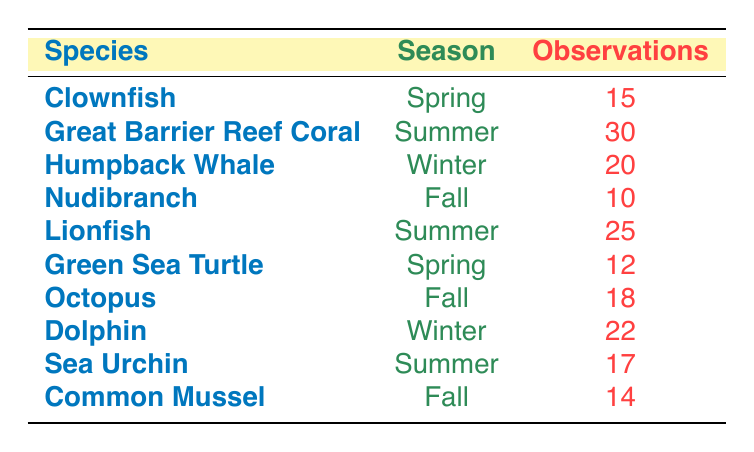What is the species with the highest observations during the Summer? In the Summer season, the species with the highest observations listed in the table is the Great Barrier Reef Coral with 30 observations.
Answer: Great Barrier Reef Coral How many observations were recorded for the Dolphin? The Dolphin species has 22 observations recorded in the table under the Winter season.
Answer: 22 Which season had the least total observations from the listed species? Adding all the observations by season, Spring has 15 (Clownfish) + 12 (Green Sea Turtle) = 27, Summer has 30 (Great Barrier Reef Coral) + 25 (Lionfish) + 17 (Sea Urchin) = 72, Winter has 20 (Humpback Whale) + 22 (Dolphin) = 42, and Fall has 10 (Nudibranch) + 18 (Octopus) + 14 (Common Mussel) = 42. The least total observations are in Spring with 27.
Answer: Spring Are there more observations of species in Winter than in Fall? In the Winter season, there are 20 (Humpback Whale) + 22 (Dolphin) = 42 observations; in the Fall season, there are 10 (Nudibranch) + 18 (Octopus) + 14 (Common Mussel) = 42 observations. Since 42 is equal for both seasons, the answer is no.
Answer: No What is the average number of observations for species in the Spring? The Spring season has two species: Clownfish with 15 observations and Green Sea Turtle with 12. The sum is 15 + 12 = 27, and there are 2 data points, so the average is 27/2 = 13.5.
Answer: 13.5 